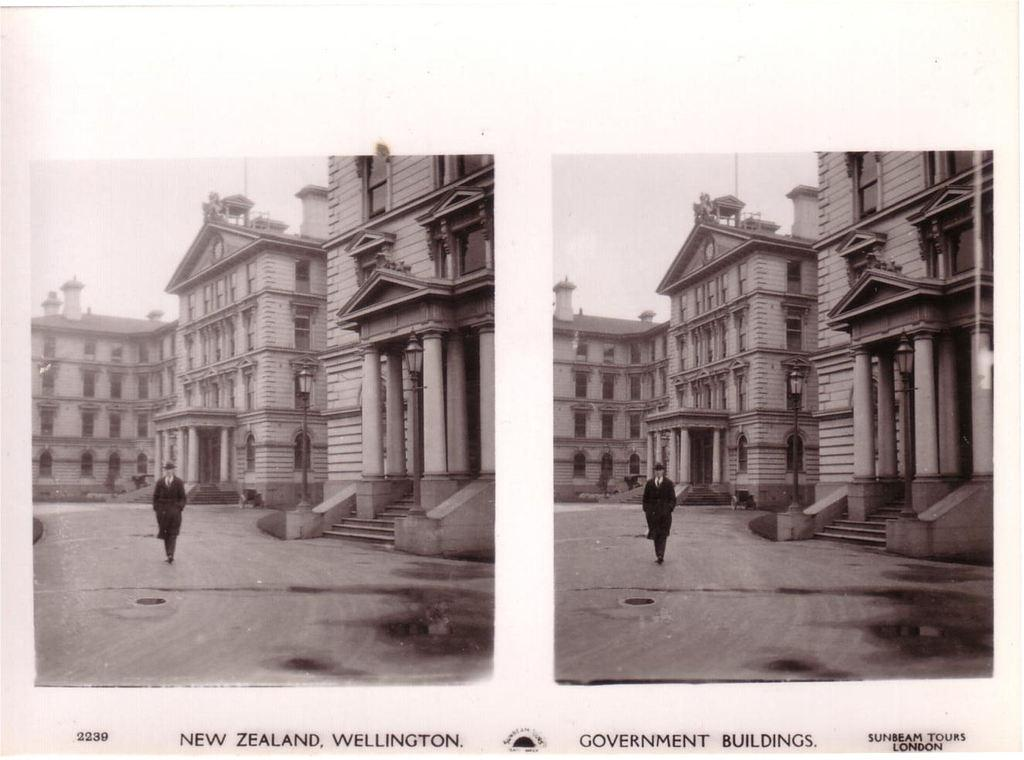What type of artwork is the image? The image is a collage. Can you identify any subjects in the collage? Yes, there is a person in the image. What else can be seen in the collage besides the person? There are buildings in the image. What type of wing is visible in the image? There is no wing present in the image; it is a collage featuring a person and buildings. Is there a basketball game happening in the image? There is no basketball game or any reference to basketball in the image. 